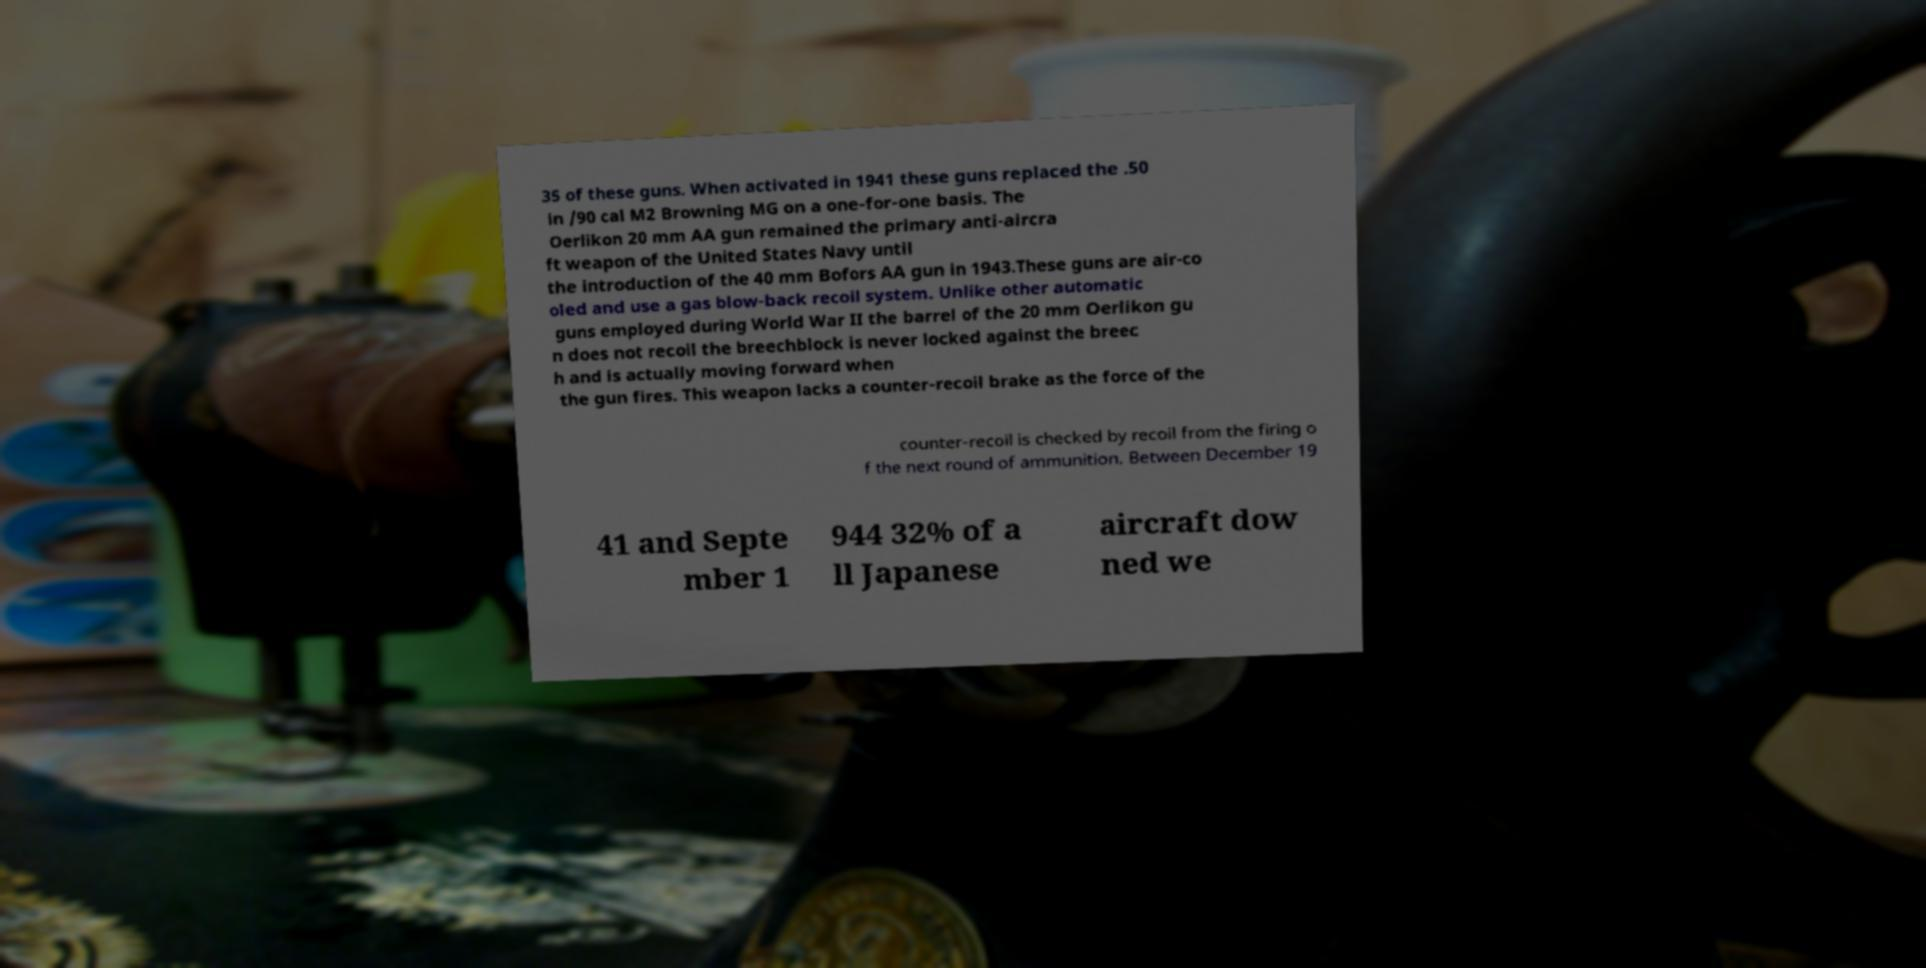Could you assist in decoding the text presented in this image and type it out clearly? 35 of these guns. When activated in 1941 these guns replaced the .50 in /90 cal M2 Browning MG on a one-for-one basis. The Oerlikon 20 mm AA gun remained the primary anti-aircra ft weapon of the United States Navy until the introduction of the 40 mm Bofors AA gun in 1943.These guns are air-co oled and use a gas blow-back recoil system. Unlike other automatic guns employed during World War II the barrel of the 20 mm Oerlikon gu n does not recoil the breechblock is never locked against the breec h and is actually moving forward when the gun fires. This weapon lacks a counter-recoil brake as the force of the counter-recoil is checked by recoil from the firing o f the next round of ammunition. Between December 19 41 and Septe mber 1 944 32% of a ll Japanese aircraft dow ned we 